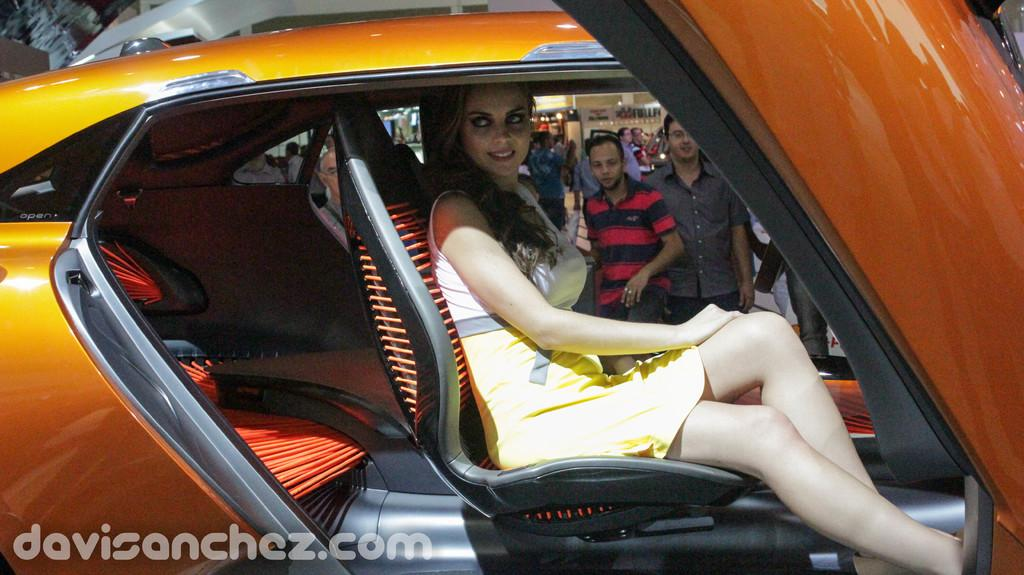What is the woman in the image doing? The woman is sitting inside a car. What can be seen in the background of the image? There is a store visible in the background, and there are persons standing in the background. How many snakes are visible in the image? There are no snakes present in the image. What type of income can be earned from the store in the image? The image does not provide information about the store's income or any financial transactions. 